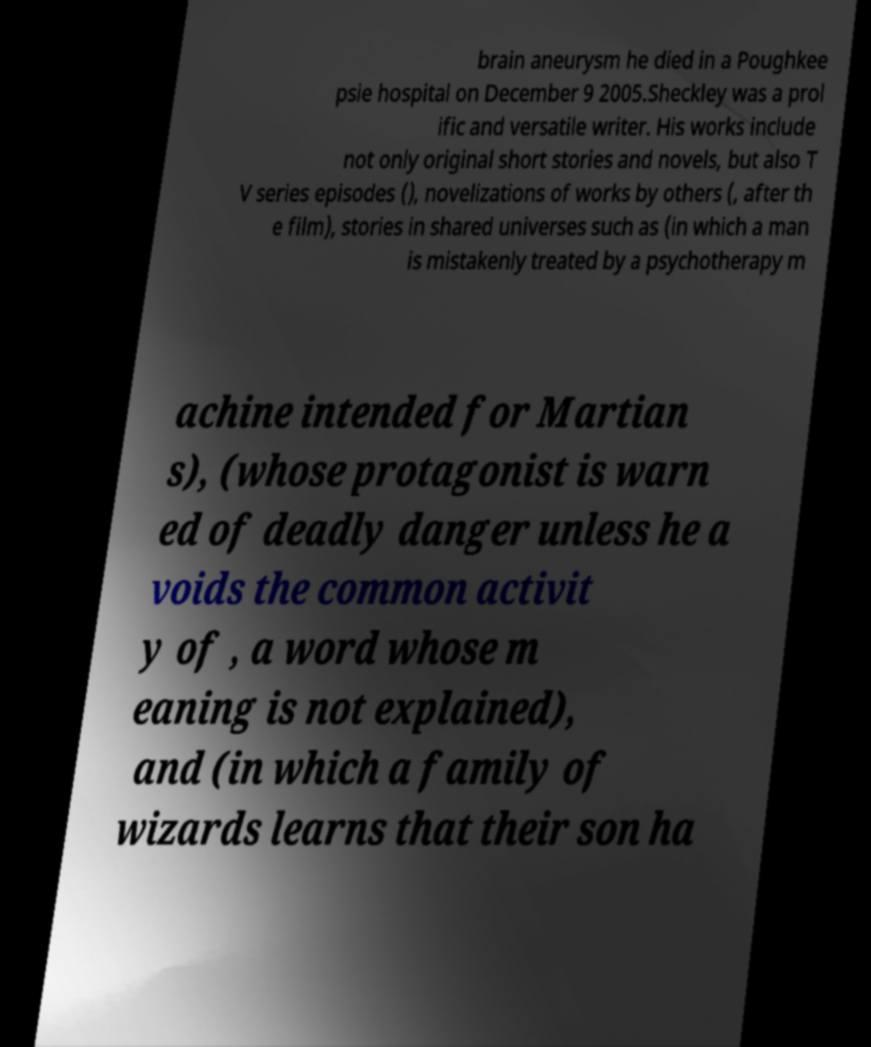There's text embedded in this image that I need extracted. Can you transcribe it verbatim? brain aneurysm he died in a Poughkee psie hospital on December 9 2005.Sheckley was a prol ific and versatile writer. His works include not only original short stories and novels, but also T V series episodes (), novelizations of works by others (, after th e film), stories in shared universes such as (in which a man is mistakenly treated by a psychotherapy m achine intended for Martian s), (whose protagonist is warn ed of deadly danger unless he a voids the common activit y of , a word whose m eaning is not explained), and (in which a family of wizards learns that their son ha 